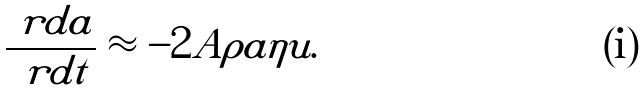<formula> <loc_0><loc_0><loc_500><loc_500>\frac { \ r d a } { \ r d t } \approx - 2 A \rho a \eta u .</formula> 